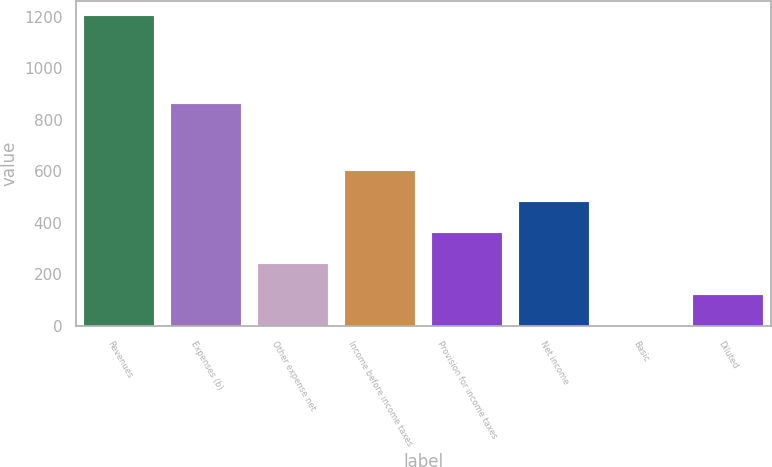<chart> <loc_0><loc_0><loc_500><loc_500><bar_chart><fcel>Revenues<fcel>Expenses (b)<fcel>Other expense net<fcel>Income before income taxes<fcel>Provision for income taxes<fcel>Net income<fcel>Basic<fcel>Diluted<nl><fcel>1201.2<fcel>860.3<fcel>240.5<fcel>600.77<fcel>360.59<fcel>480.68<fcel>0.32<fcel>120.41<nl></chart> 